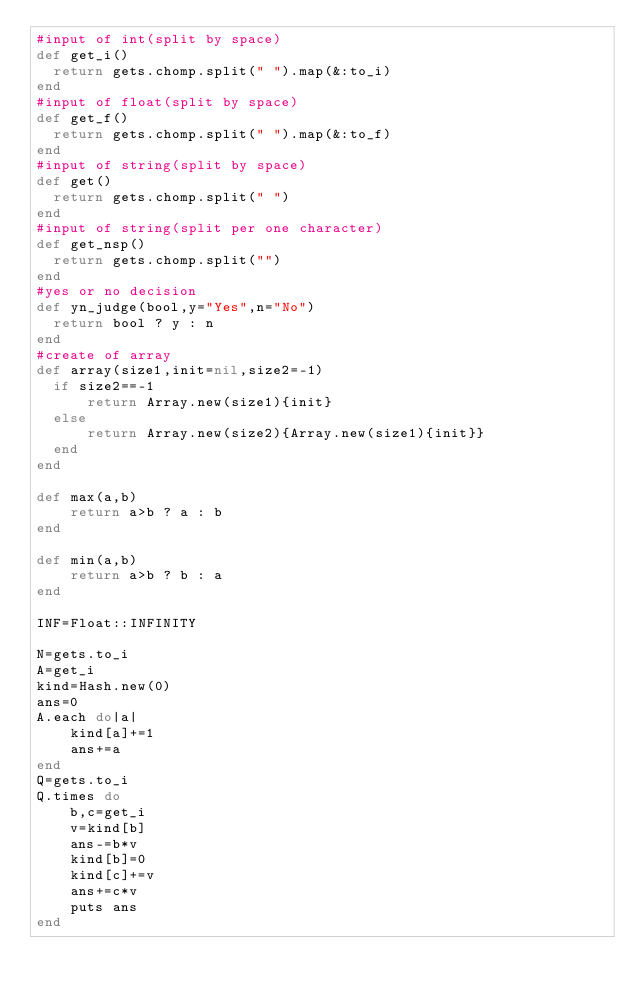Convert code to text. <code><loc_0><loc_0><loc_500><loc_500><_Ruby_>#input of int(split by space)
def get_i()
  return gets.chomp.split(" ").map(&:to_i)
end
#input of float(split by space)
def get_f()
  return gets.chomp.split(" ").map(&:to_f)
end
#input of string(split by space)
def get()
  return gets.chomp.split(" ")
end
#input of string(split per one character)
def get_nsp()
  return gets.chomp.split("")
end
#yes or no decision
def yn_judge(bool,y="Yes",n="No")
  return bool ? y : n 
end
#create of array
def array(size1,init=nil,size2=-1)
  if size2==-1
      return Array.new(size1){init}
  else
      return Array.new(size2){Array.new(size1){init}}
  end
end

def max(a,b)
    return a>b ? a : b
end

def min(a,b)
    return a>b ? b : a
end

INF=Float::INFINITY

N=gets.to_i
A=get_i
kind=Hash.new(0)
ans=0
A.each do|a|
    kind[a]+=1
    ans+=a
end
Q=gets.to_i
Q.times do
    b,c=get_i
    v=kind[b]
    ans-=b*v
    kind[b]=0
    kind[c]+=v
    ans+=c*v
    puts ans
end</code> 